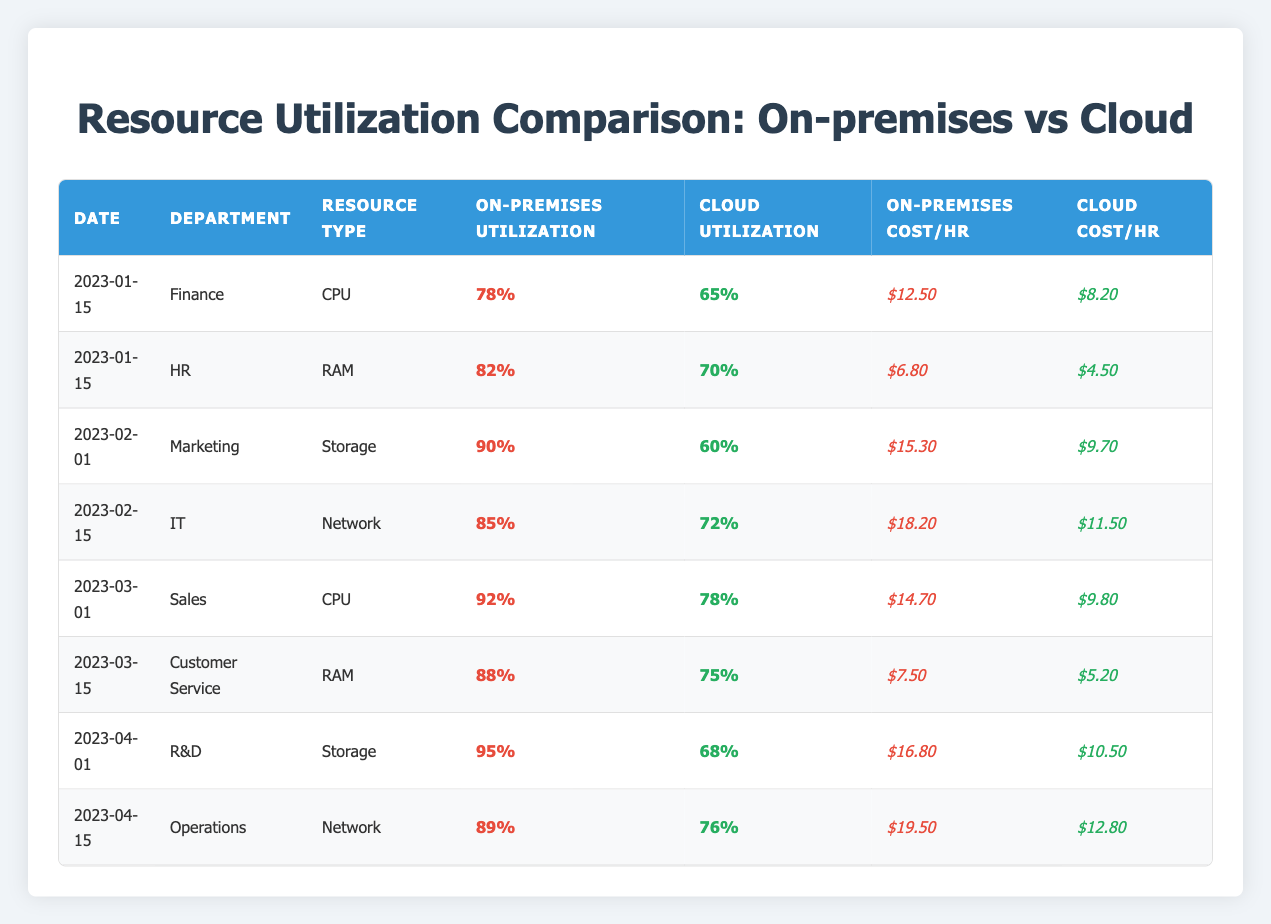What is the CPU utilization percentage for the On-premises environment on 2023-03-01? The table shows that on 2023-03-01, the CPU utilization percentage for the On-premises environment is listed as 92%.
Answer: 92% What is the cost per hour of Cloud RAM for the HR department on 2023-01-15? According to the table, the cost per hour of Cloud RAM for the HR department on 2023-01-15 is $4.50.
Answer: $4.50 Which department had the highest on-premises utilization percentage for storage resources, and what was that percentage? The R&D department had the highest on-premises utilization percentage for storage resources at 95% on 2023-04-01.
Answer: R&D - 95% What is the difference in CPU utilization percentage between Cloud and On-premises for the Finance department on 2023-01-15? The CPU utilization for On-premises is 78% and for Cloud is 65%. The difference is calculated as 78% - 65% = 13%.
Answer: 13% Is the cost per hour for On-premises Network resources generally higher than that for Cloud resources? Yes, in all instances where a comparison is present, the cost per hour for On-premises Network resources is higher than that for Cloud resources (19.50 vs. 12.80, etc.).
Answer: Yes What is the average Cloud utilization percentage for all resource types across all departments? To find the average Cloud utilization percentage, sum the percentages (65 + 70 + 60 + 72 + 78 + 75 + 68 + 76) = 530, then divide by the number of data points (8), resulting in 530/8 = 66.25%.
Answer: 66.25% Which resource type had the lowest Cloud utilization percentage and what was that percentage? Looking at all Cloud utilization entries, Storage had the lowest percentage at 60% on 2023-02-01.
Answer: Storage - 60% For the IT department, how much more expensive per hour is On-premises Network compared to Cloud Network on 2023-02-15? The On-premises Network cost per hour is $18.20 while the Cloud Network cost per hour is $11.50. The difference is calculated as $18.20 - $11.50 = $6.70.
Answer: $6.70 What is the utilization percentage for RAM in the Cloud for the Customer Service department on 2023-03-15? The table indicates that the utilization percentage for RAM in the Cloud for the Customer Service department on 2023-03-15 is 75%.
Answer: 75% 